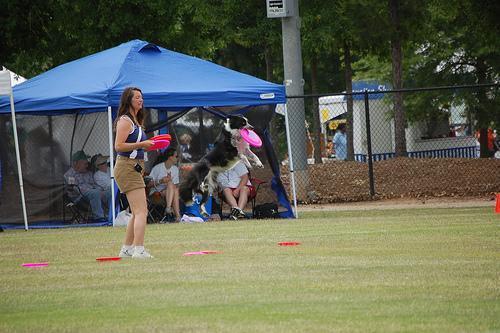How many people are there standing on the field?
Give a very brief answer. 1. 